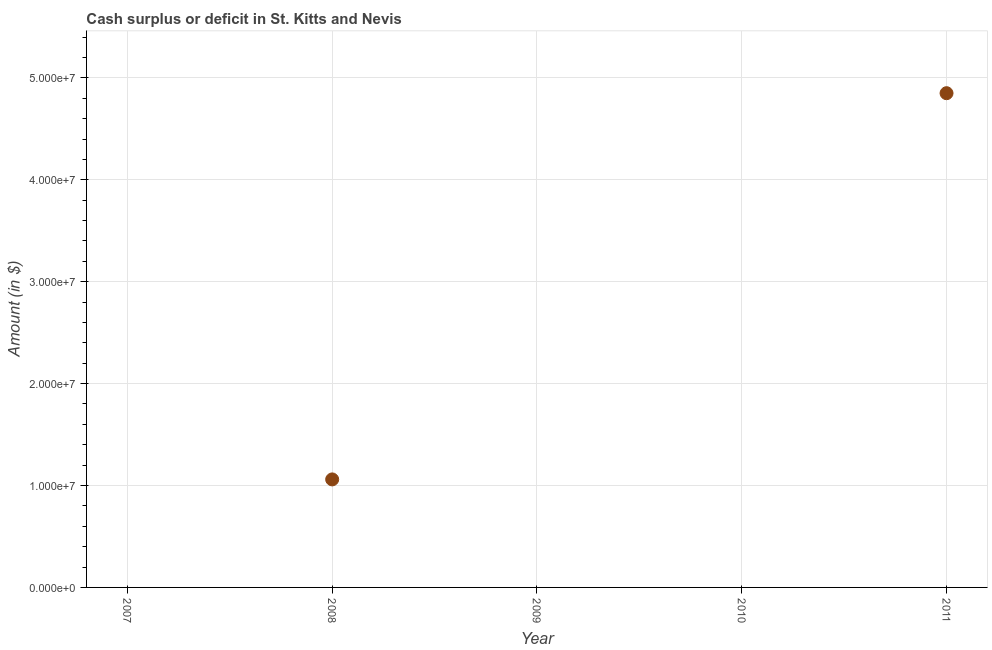What is the cash surplus or deficit in 2011?
Your answer should be compact. 4.85e+07. Across all years, what is the maximum cash surplus or deficit?
Your response must be concise. 4.85e+07. What is the sum of the cash surplus or deficit?
Provide a succinct answer. 5.91e+07. What is the average cash surplus or deficit per year?
Offer a terse response. 1.18e+07. What is the median cash surplus or deficit?
Give a very brief answer. 0. Is the difference between the cash surplus or deficit in 2008 and 2011 greater than the difference between any two years?
Provide a short and direct response. No. What is the difference between the highest and the lowest cash surplus or deficit?
Ensure brevity in your answer.  4.85e+07. How many years are there in the graph?
Give a very brief answer. 5. What is the difference between two consecutive major ticks on the Y-axis?
Offer a very short reply. 1.00e+07. Does the graph contain any zero values?
Your answer should be compact. Yes. What is the title of the graph?
Your answer should be compact. Cash surplus or deficit in St. Kitts and Nevis. What is the label or title of the X-axis?
Provide a short and direct response. Year. What is the label or title of the Y-axis?
Your response must be concise. Amount (in $). What is the Amount (in $) in 2007?
Provide a short and direct response. 0. What is the Amount (in $) in 2008?
Your answer should be very brief. 1.06e+07. What is the Amount (in $) in 2011?
Your answer should be compact. 4.85e+07. What is the difference between the Amount (in $) in 2008 and 2011?
Your answer should be compact. -3.79e+07. What is the ratio of the Amount (in $) in 2008 to that in 2011?
Keep it short and to the point. 0.22. 